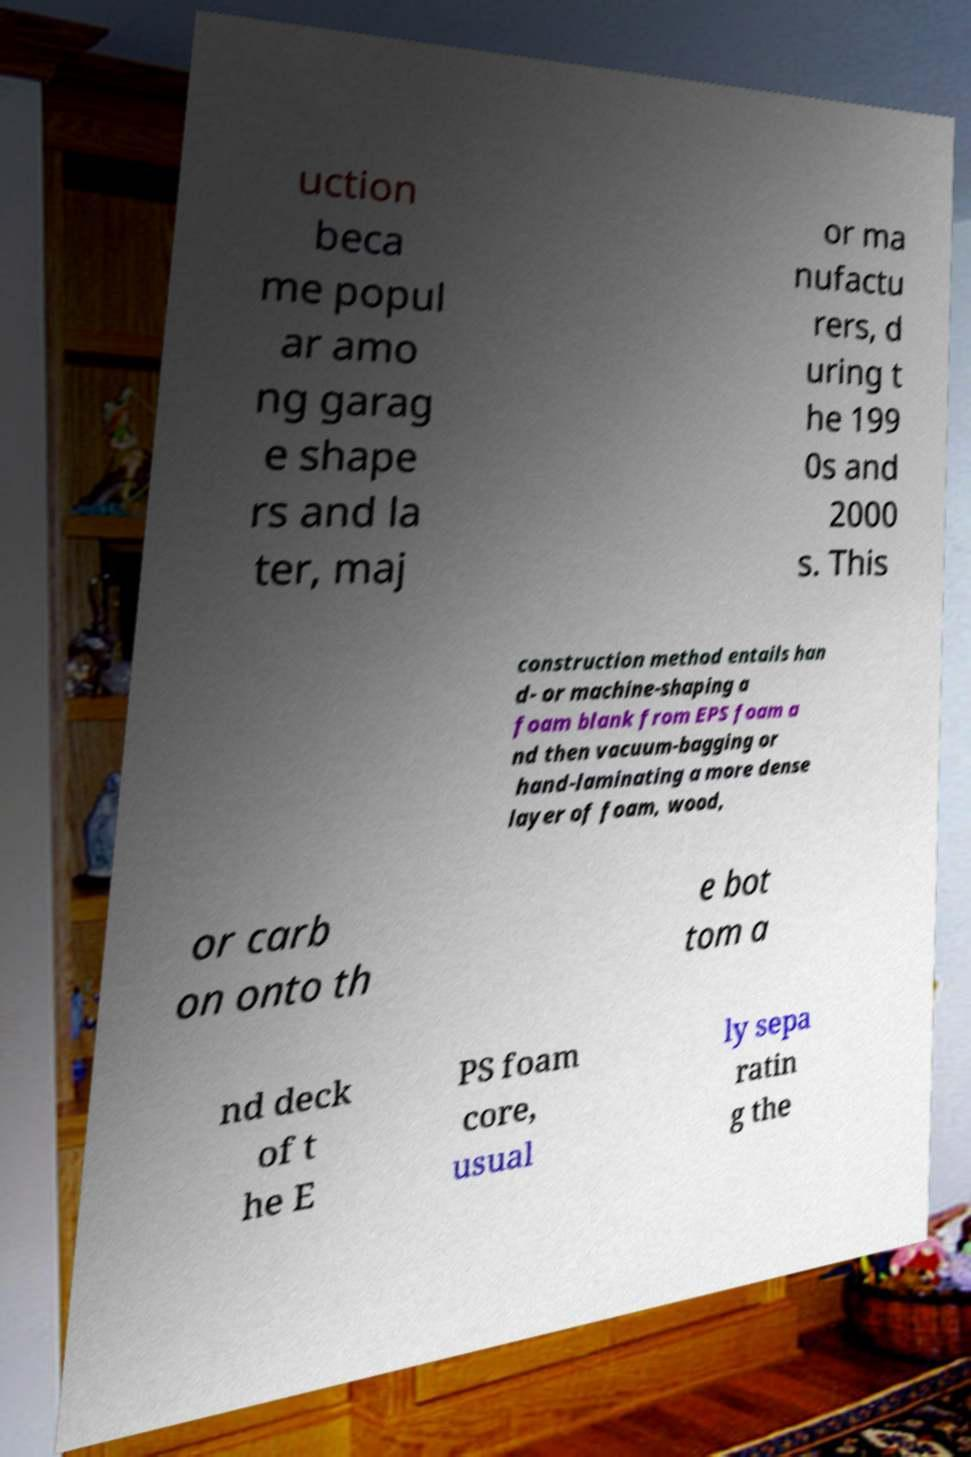Could you assist in decoding the text presented in this image and type it out clearly? uction beca me popul ar amo ng garag e shape rs and la ter, maj or ma nufactu rers, d uring t he 199 0s and 2000 s. This construction method entails han d- or machine-shaping a foam blank from EPS foam a nd then vacuum-bagging or hand-laminating a more dense layer of foam, wood, or carb on onto th e bot tom a nd deck of t he E PS foam core, usual ly sepa ratin g the 